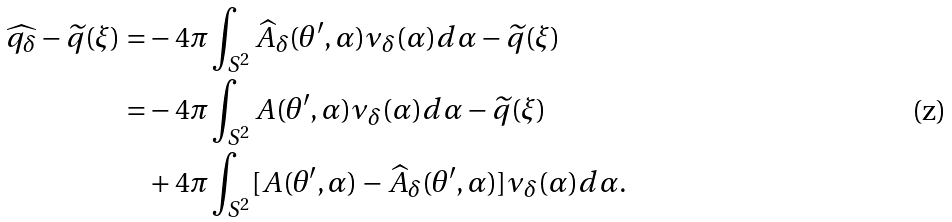<formula> <loc_0><loc_0><loc_500><loc_500>\widehat { q _ { \delta } } - \widetilde { q } ( \xi ) = & - 4 \pi \int _ { S ^ { 2 } } \widehat { A } _ { \delta } ( \theta ^ { \prime } , \alpha ) \nu _ { \delta } ( \alpha ) d \alpha - \widetilde { q } ( \xi ) \\ = & - 4 \pi \int _ { S ^ { 2 } } A ( \theta ^ { \prime } , \alpha ) \nu _ { \delta } ( \alpha ) d \alpha - \widetilde { q } ( \xi ) \\ & + 4 \pi \int _ { S ^ { 2 } } [ A ( \theta ^ { \prime } , \alpha ) - \widehat { A } _ { \delta } ( \theta ^ { \prime } , \alpha ) ] \nu _ { \delta } ( \alpha ) d \alpha .</formula> 